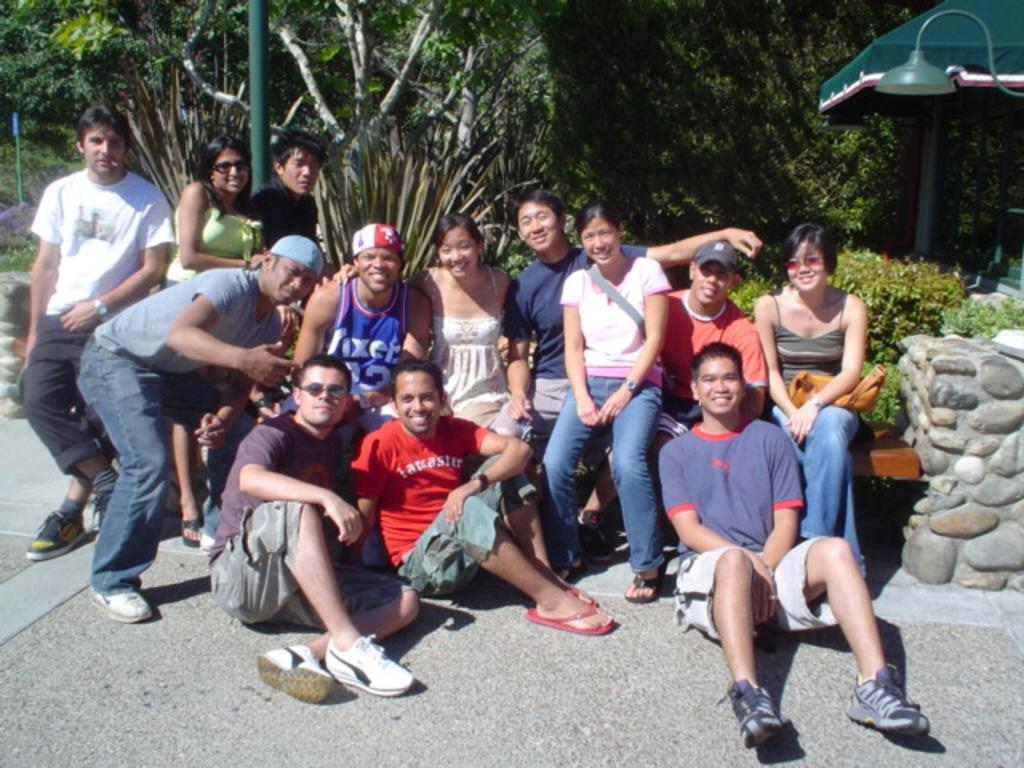How many people are in the image? There is a group of people in the image, but the exact number is not specified. What are the people in the image doing? Some people are sitting on the ground, and some are standing on the ground. What can be seen in the background of the image? There are trees, poles, plants, and other unspecified objects in the background of the image. What type of bulb is hanging from the tree in the image? There is no bulb hanging from a tree in the image; there are only trees, poles, plants, and other unspecified objects in the background. How many rats are visible in the image? There are no rats present in the image. 